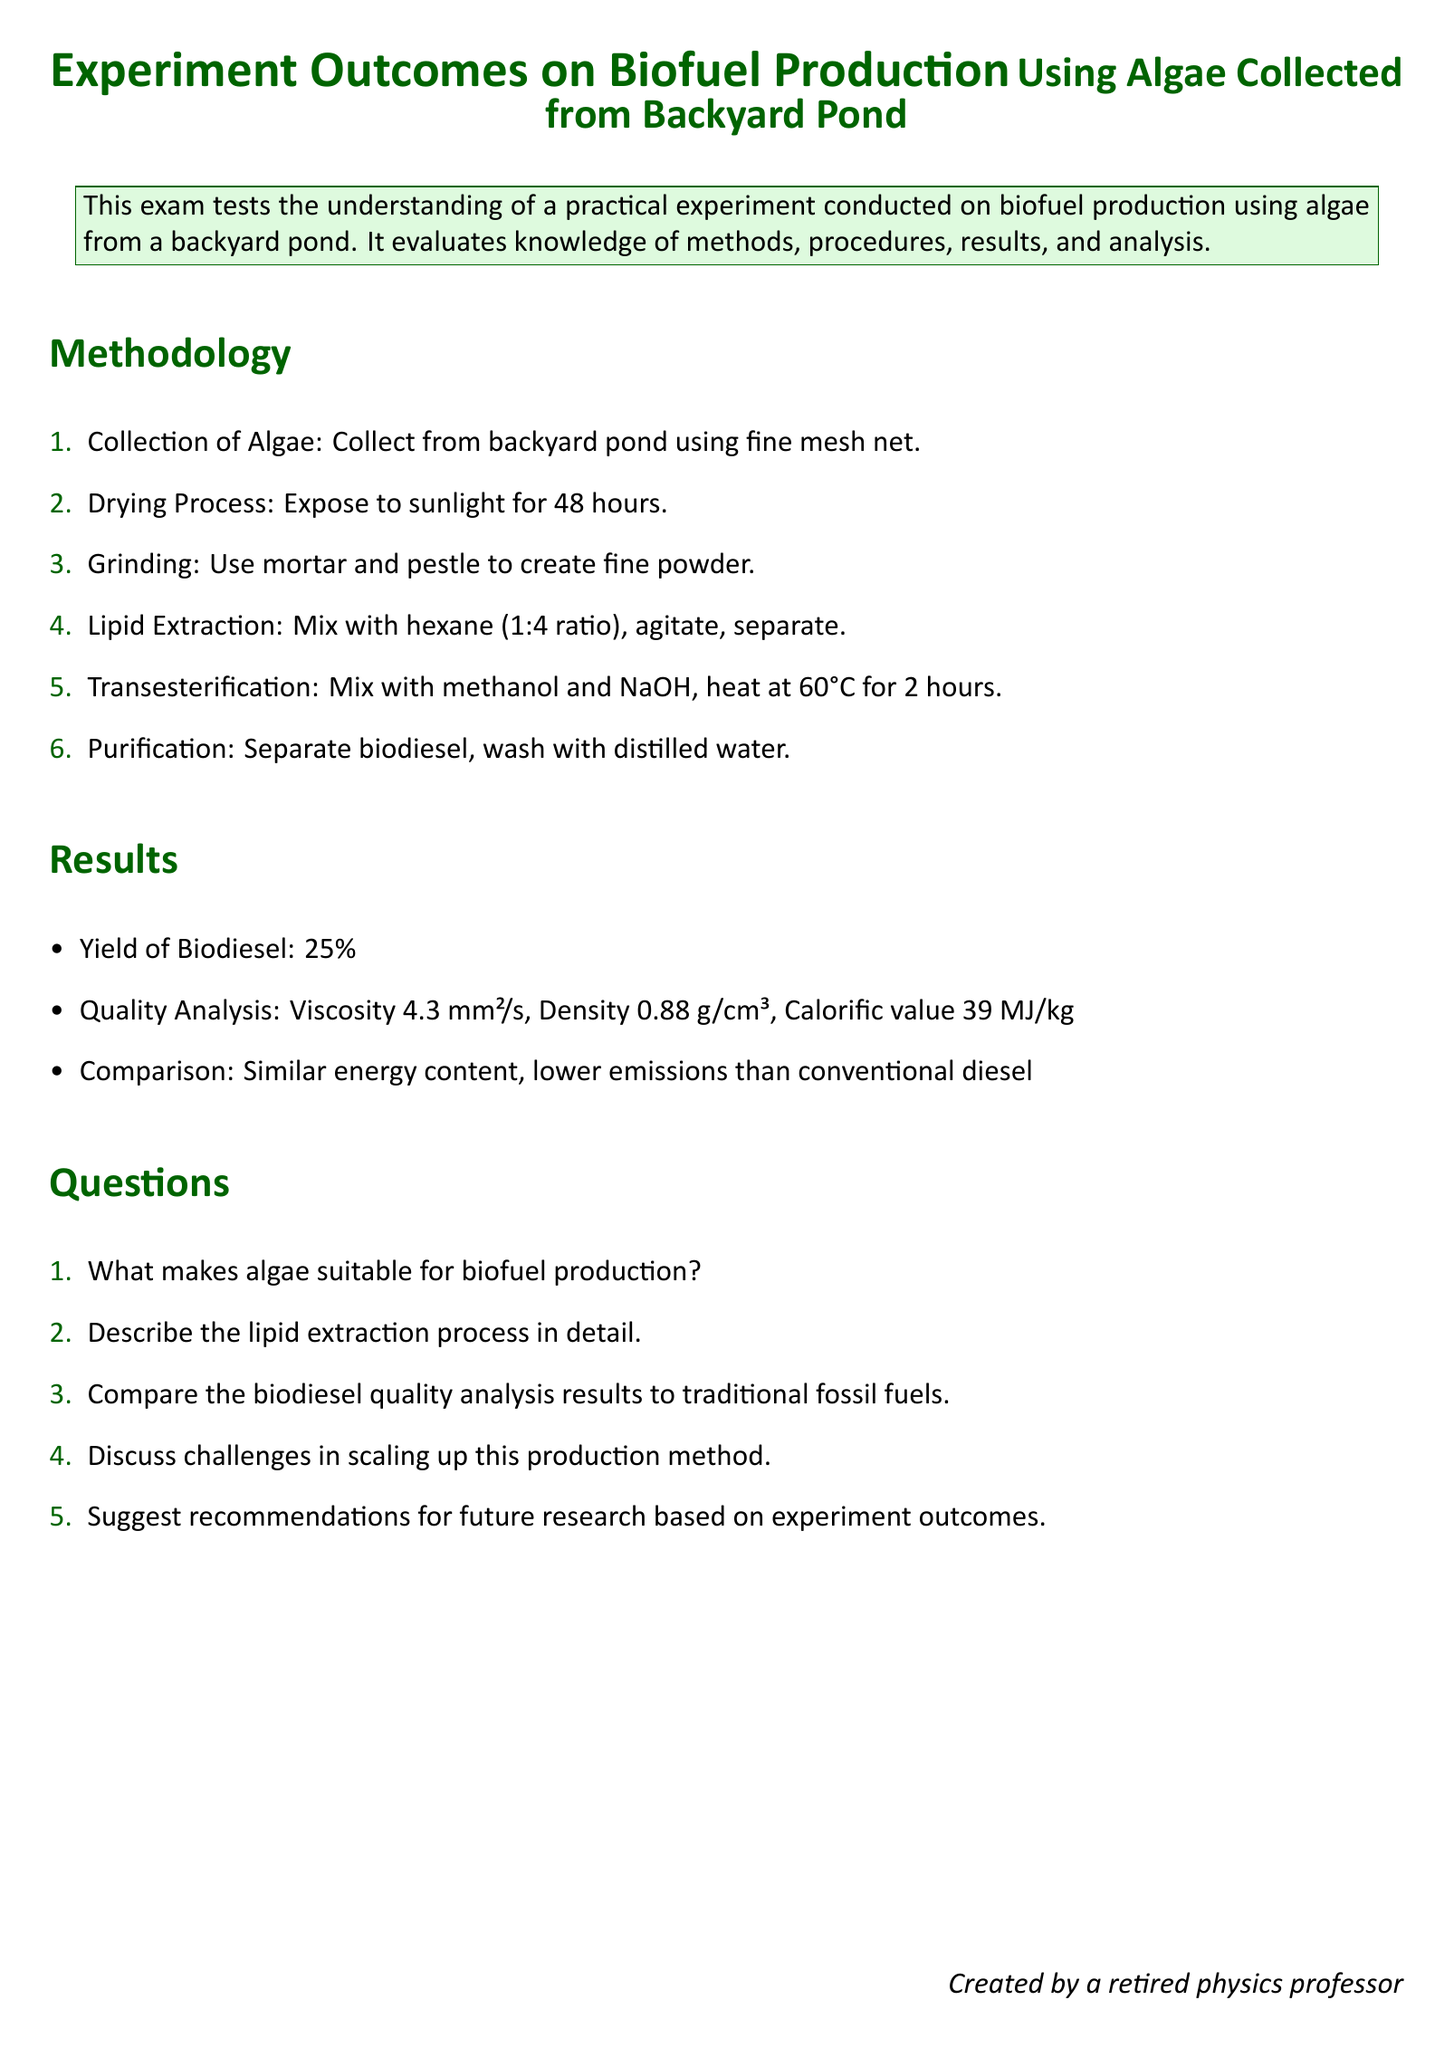What is the yield of biodiesel? The yield of biodiesel is specified in the results section of the document, indicating the percentage of biodiesel produced from the algae.
Answer: 25% What is the drying process duration? The methodology outlines the drying process, clearly stating the time duration for exposing the algae to sunlight.
Answer: 48 hours What ratio of hexane was used for lipid extraction? The lipid extraction method in the document specifies the mixture ratio of hexane to algae, which is important for the extraction efficiency.
Answer: 1:4 What is the viscosity of the produced biodiesel? The quality analysis section lists the measurements of the biodiesel, including its viscosity, thus providing a measurement of its flow characteristics.
Answer: 4.3 mm²/s How long was the transesterification process conducted? The methodology describes the duration of heating during the transesterification process, crucial for converting oils into biodiesel.
Answer: 2 hours What characteristics are compared with conventional diesel? The results section mentions comparisons made between the biofuel and conventional fossil fuels, focusing on specific traits.
Answer: Energy content, emissions What is a challenge mentioned in scaling up the production method? One consideration in the challenges of scaling up biofuel production is likely discussed in the reasoning questions of the document, which speaks to the practical aspects of biofuel production.
Answer: Cost, efficiency, supply What is suggested for future research? A question in the document prompts for recommendations based on the experiment outcomes, indicating the direction for future studies.
Answer: Algae species, process optimization 